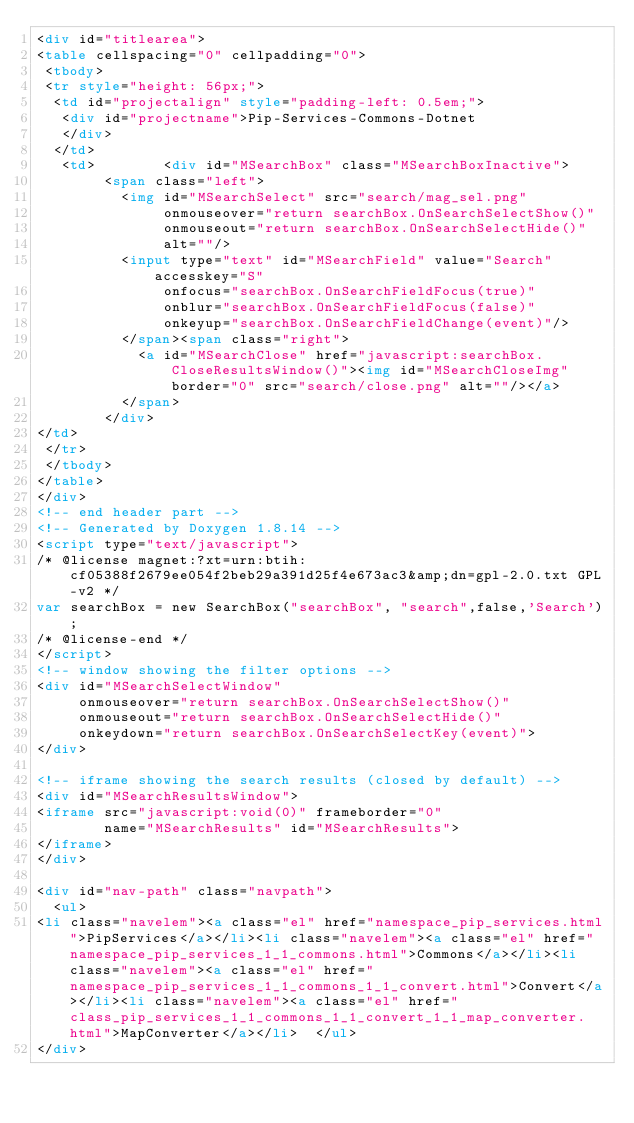Convert code to text. <code><loc_0><loc_0><loc_500><loc_500><_HTML_><div id="titlearea">
<table cellspacing="0" cellpadding="0">
 <tbody>
 <tr style="height: 56px;">
  <td id="projectalign" style="padding-left: 0.5em;">
   <div id="projectname">Pip-Services-Commons-Dotnet
   </div>
  </td>
   <td>        <div id="MSearchBox" class="MSearchBoxInactive">
        <span class="left">
          <img id="MSearchSelect" src="search/mag_sel.png"
               onmouseover="return searchBox.OnSearchSelectShow()"
               onmouseout="return searchBox.OnSearchSelectHide()"
               alt=""/>
          <input type="text" id="MSearchField" value="Search" accesskey="S"
               onfocus="searchBox.OnSearchFieldFocus(true)" 
               onblur="searchBox.OnSearchFieldFocus(false)" 
               onkeyup="searchBox.OnSearchFieldChange(event)"/>
          </span><span class="right">
            <a id="MSearchClose" href="javascript:searchBox.CloseResultsWindow()"><img id="MSearchCloseImg" border="0" src="search/close.png" alt=""/></a>
          </span>
        </div>
</td>
 </tr>
 </tbody>
</table>
</div>
<!-- end header part -->
<!-- Generated by Doxygen 1.8.14 -->
<script type="text/javascript">
/* @license magnet:?xt=urn:btih:cf05388f2679ee054f2beb29a391d25f4e673ac3&amp;dn=gpl-2.0.txt GPL-v2 */
var searchBox = new SearchBox("searchBox", "search",false,'Search');
/* @license-end */
</script>
<!-- window showing the filter options -->
<div id="MSearchSelectWindow"
     onmouseover="return searchBox.OnSearchSelectShow()"
     onmouseout="return searchBox.OnSearchSelectHide()"
     onkeydown="return searchBox.OnSearchSelectKey(event)">
</div>

<!-- iframe showing the search results (closed by default) -->
<div id="MSearchResultsWindow">
<iframe src="javascript:void(0)" frameborder="0" 
        name="MSearchResults" id="MSearchResults">
</iframe>
</div>

<div id="nav-path" class="navpath">
  <ul>
<li class="navelem"><a class="el" href="namespace_pip_services.html">PipServices</a></li><li class="navelem"><a class="el" href="namespace_pip_services_1_1_commons.html">Commons</a></li><li class="navelem"><a class="el" href="namespace_pip_services_1_1_commons_1_1_convert.html">Convert</a></li><li class="navelem"><a class="el" href="class_pip_services_1_1_commons_1_1_convert_1_1_map_converter.html">MapConverter</a></li>  </ul>
</div></code> 